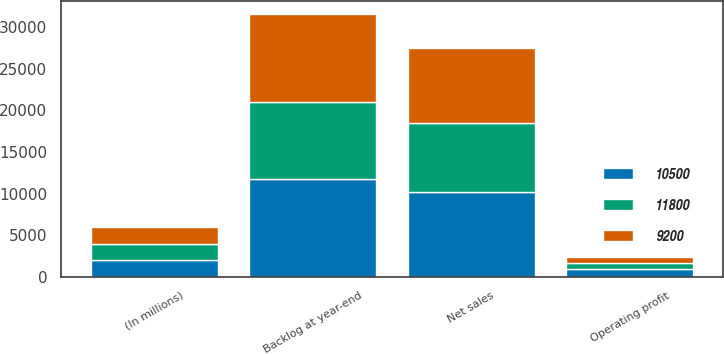Convert chart. <chart><loc_0><loc_0><loc_500><loc_500><stacked_bar_chart><ecel><fcel>(In millions)<fcel>Net sales<fcel>Operating profit<fcel>Backlog at year-end<nl><fcel>10500<fcel>2007<fcel>10213<fcel>949<fcel>11800<nl><fcel>9200<fcel>2006<fcel>8990<fcel>804<fcel>10500<nl><fcel>11800<fcel>2005<fcel>8233<fcel>720<fcel>9200<nl></chart> 